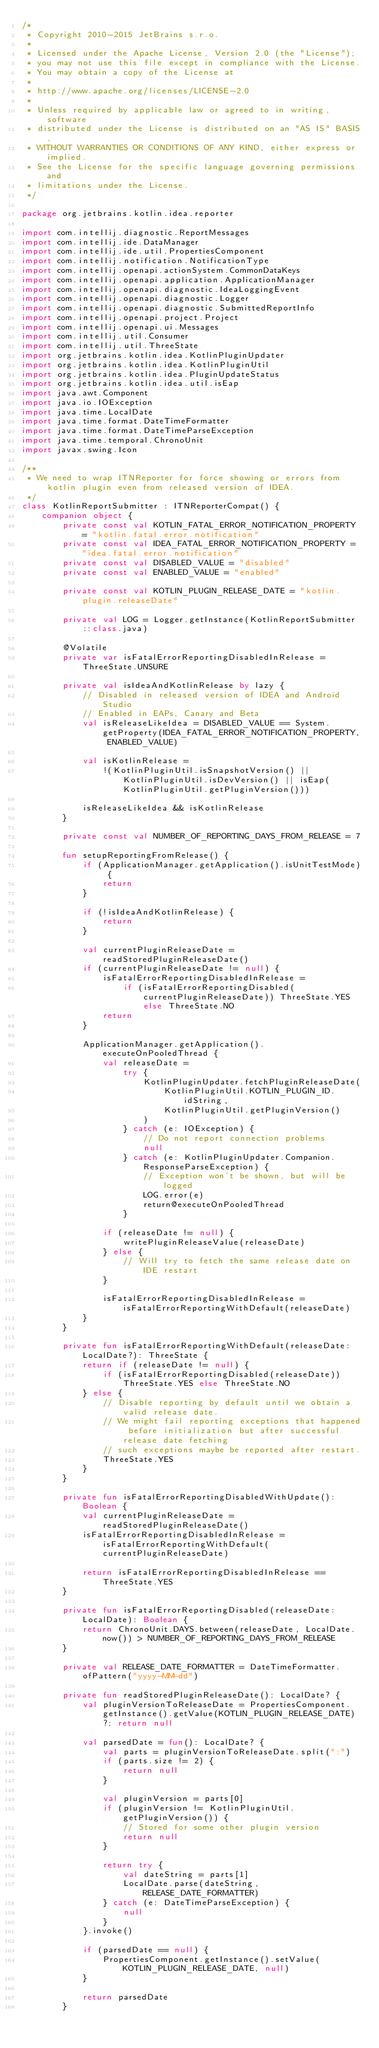Convert code to text. <code><loc_0><loc_0><loc_500><loc_500><_Kotlin_>/*
 * Copyright 2010-2015 JetBrains s.r.o.
 *
 * Licensed under the Apache License, Version 2.0 (the "License");
 * you may not use this file except in compliance with the License.
 * You may obtain a copy of the License at
 *
 * http://www.apache.org/licenses/LICENSE-2.0
 *
 * Unless required by applicable law or agreed to in writing, software
 * distributed under the License is distributed on an "AS IS" BASIS,
 * WITHOUT WARRANTIES OR CONDITIONS OF ANY KIND, either express or implied.
 * See the License for the specific language governing permissions and
 * limitations under the License.
 */

package org.jetbrains.kotlin.idea.reporter

import com.intellij.diagnostic.ReportMessages
import com.intellij.ide.DataManager
import com.intellij.ide.util.PropertiesComponent
import com.intellij.notification.NotificationType
import com.intellij.openapi.actionSystem.CommonDataKeys
import com.intellij.openapi.application.ApplicationManager
import com.intellij.openapi.diagnostic.IdeaLoggingEvent
import com.intellij.openapi.diagnostic.Logger
import com.intellij.openapi.diagnostic.SubmittedReportInfo
import com.intellij.openapi.project.Project
import com.intellij.openapi.ui.Messages
import com.intellij.util.Consumer
import com.intellij.util.ThreeState
import org.jetbrains.kotlin.idea.KotlinPluginUpdater
import org.jetbrains.kotlin.idea.KotlinPluginUtil
import org.jetbrains.kotlin.idea.PluginUpdateStatus
import org.jetbrains.kotlin.idea.util.isEap
import java.awt.Component
import java.io.IOException
import java.time.LocalDate
import java.time.format.DateTimeFormatter
import java.time.format.DateTimeParseException
import java.time.temporal.ChronoUnit
import javax.swing.Icon

/**
 * We need to wrap ITNReporter for force showing or errors from kotlin plugin even from released version of IDEA.
 */
class KotlinReportSubmitter : ITNReporterCompat() {
    companion object {
        private const val KOTLIN_FATAL_ERROR_NOTIFICATION_PROPERTY = "kotlin.fatal.error.notification"
        private const val IDEA_FATAL_ERROR_NOTIFICATION_PROPERTY = "idea.fatal.error.notification"
        private const val DISABLED_VALUE = "disabled"
        private const val ENABLED_VALUE = "enabled"

        private const val KOTLIN_PLUGIN_RELEASE_DATE = "kotlin.plugin.releaseDate"

        private val LOG = Logger.getInstance(KotlinReportSubmitter::class.java)

        @Volatile
        private var isFatalErrorReportingDisabledInRelease = ThreeState.UNSURE

        private val isIdeaAndKotlinRelease by lazy {
            // Disabled in released version of IDEA and Android Studio
            // Enabled in EAPs, Canary and Beta
            val isReleaseLikeIdea = DISABLED_VALUE == System.getProperty(IDEA_FATAL_ERROR_NOTIFICATION_PROPERTY, ENABLED_VALUE)

            val isKotlinRelease =
                !(KotlinPluginUtil.isSnapshotVersion() || KotlinPluginUtil.isDevVersion() || isEap(KotlinPluginUtil.getPluginVersion()))

            isReleaseLikeIdea && isKotlinRelease
        }

        private const val NUMBER_OF_REPORTING_DAYS_FROM_RELEASE = 7

        fun setupReportingFromRelease() {
            if (ApplicationManager.getApplication().isUnitTestMode) {
                return
            }

            if (!isIdeaAndKotlinRelease) {
                return
            }

            val currentPluginReleaseDate = readStoredPluginReleaseDate()
            if (currentPluginReleaseDate != null) {
                isFatalErrorReportingDisabledInRelease =
                    if (isFatalErrorReportingDisabled(currentPluginReleaseDate)) ThreeState.YES else ThreeState.NO
                return
            }

            ApplicationManager.getApplication().executeOnPooledThread {
                val releaseDate =
                    try {
                        KotlinPluginUpdater.fetchPluginReleaseDate(
                            KotlinPluginUtil.KOTLIN_PLUGIN_ID.idString,
                            KotlinPluginUtil.getPluginVersion()
                        )
                    } catch (e: IOException) {
                        // Do not report connection problems
                        null
                    } catch (e: KotlinPluginUpdater.Companion.ResponseParseException) {
                        // Exception won't be shown, but will be logged
                        LOG.error(e)
                        return@executeOnPooledThread
                    }

                if (releaseDate != null) {
                    writePluginReleaseValue(releaseDate)
                } else {
                    // Will try to fetch the same release date on IDE restart
                }

                isFatalErrorReportingDisabledInRelease = isFatalErrorReportingWithDefault(releaseDate)
            }
        }

        private fun isFatalErrorReportingWithDefault(releaseDate: LocalDate?): ThreeState {
            return if (releaseDate != null) {
                if (isFatalErrorReportingDisabled(releaseDate)) ThreeState.YES else ThreeState.NO
            } else {
                // Disable reporting by default until we obtain a valid release date.
                // We might fail reporting exceptions that happened before initialization but after successful release date fetching
                // such exceptions maybe be reported after restart.
                ThreeState.YES
            }
        }

        private fun isFatalErrorReportingDisabledWithUpdate(): Boolean {
            val currentPluginReleaseDate = readStoredPluginReleaseDate()
            isFatalErrorReportingDisabledInRelease = isFatalErrorReportingWithDefault(currentPluginReleaseDate)

            return isFatalErrorReportingDisabledInRelease == ThreeState.YES
        }

        private fun isFatalErrorReportingDisabled(releaseDate: LocalDate): Boolean {
            return ChronoUnit.DAYS.between(releaseDate, LocalDate.now()) > NUMBER_OF_REPORTING_DAYS_FROM_RELEASE
        }

        private val RELEASE_DATE_FORMATTER = DateTimeFormatter.ofPattern("yyyy-MM-dd")

        private fun readStoredPluginReleaseDate(): LocalDate? {
            val pluginVersionToReleaseDate = PropertiesComponent.getInstance().getValue(KOTLIN_PLUGIN_RELEASE_DATE) ?: return null

            val parsedDate = fun(): LocalDate? {
                val parts = pluginVersionToReleaseDate.split(":")
                if (parts.size != 2) {
                    return null
                }

                val pluginVersion = parts[0]
                if (pluginVersion != KotlinPluginUtil.getPluginVersion()) {
                    // Stored for some other plugin version
                    return null
                }

                return try {
                    val dateString = parts[1]
                    LocalDate.parse(dateString, RELEASE_DATE_FORMATTER)
                } catch (e: DateTimeParseException) {
                    null
                }
            }.invoke()

            if (parsedDate == null) {
                PropertiesComponent.getInstance().setValue(KOTLIN_PLUGIN_RELEASE_DATE, null)
            }

            return parsedDate
        }
</code> 